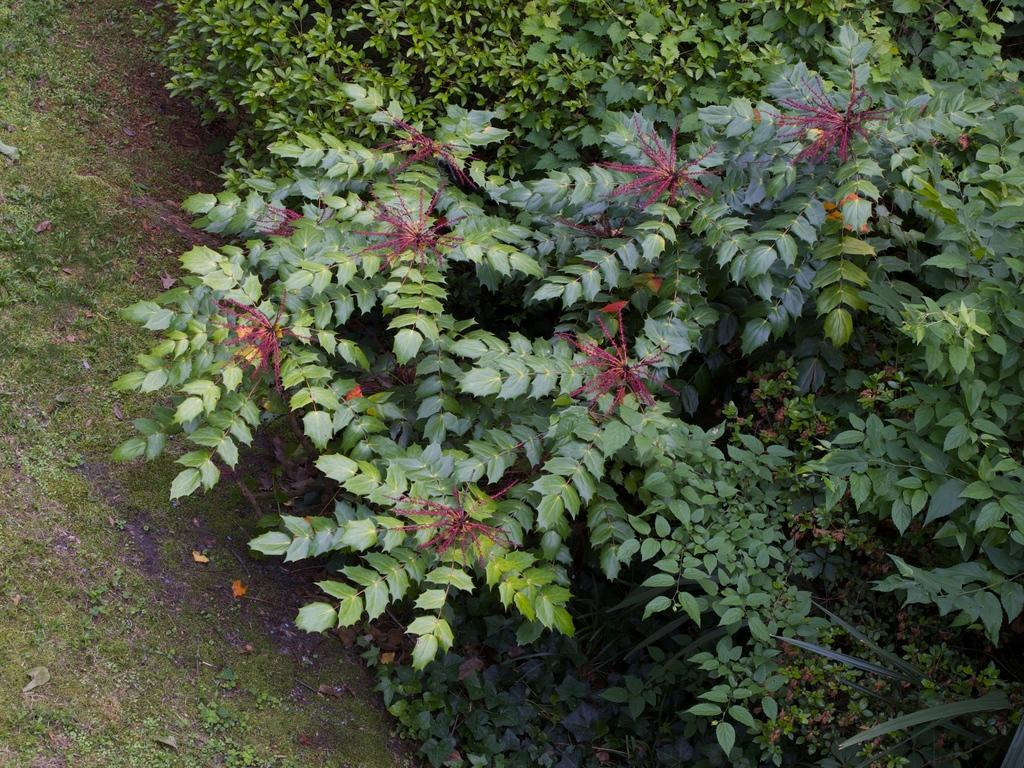What type of vegetation can be seen in the image? There are green trees in the image. What else can be seen in the image besides the trees? There is grass visible in the image. Are there any toys hanging from the icicles in the image? There are no icicles or toys present in the image. 